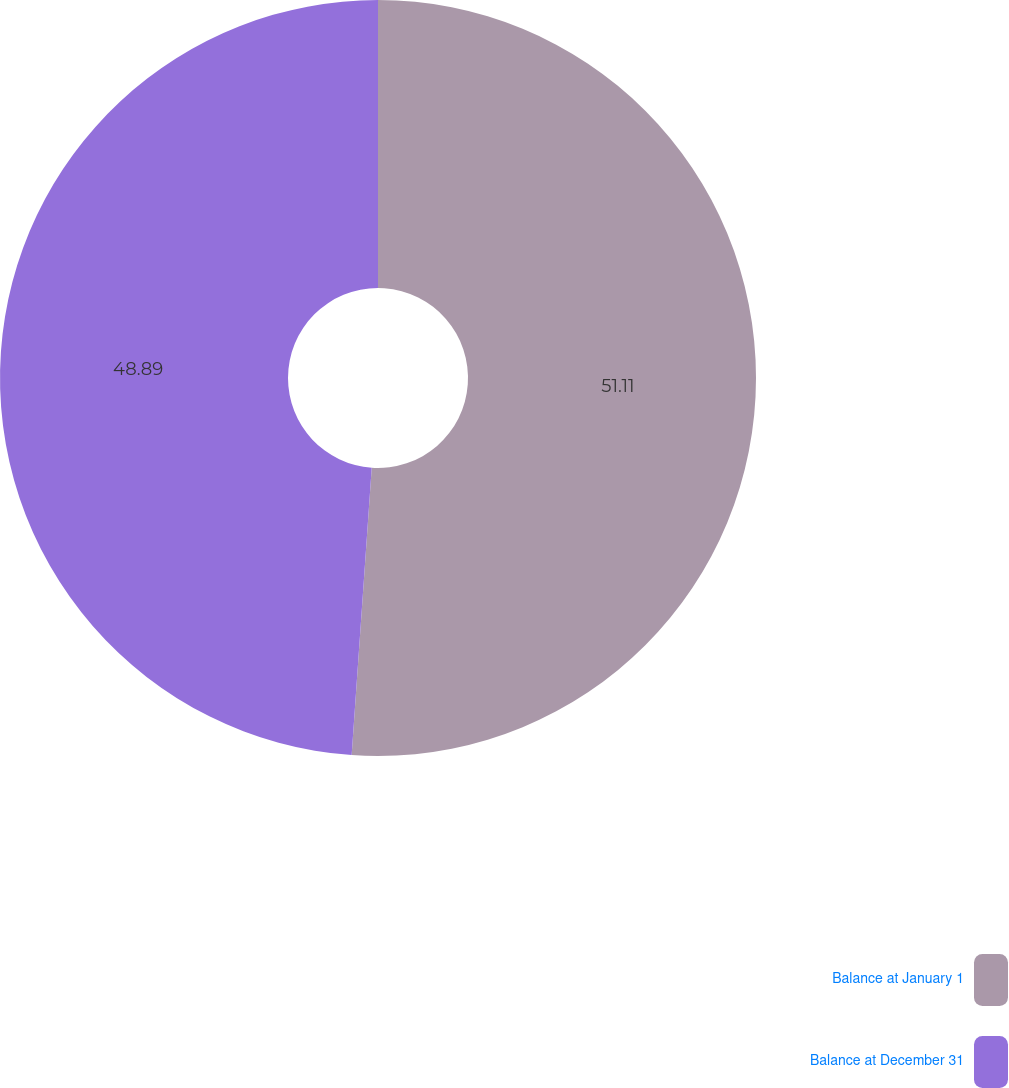<chart> <loc_0><loc_0><loc_500><loc_500><pie_chart><fcel>Balance at January 1<fcel>Balance at December 31<nl><fcel>51.11%<fcel>48.89%<nl></chart> 